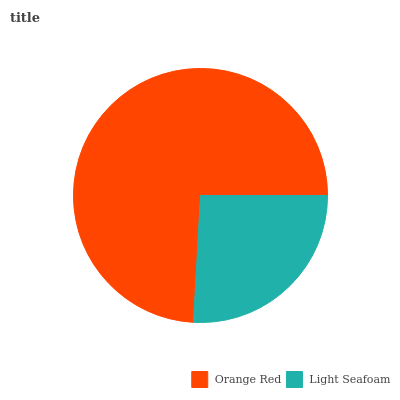Is Light Seafoam the minimum?
Answer yes or no. Yes. Is Orange Red the maximum?
Answer yes or no. Yes. Is Light Seafoam the maximum?
Answer yes or no. No. Is Orange Red greater than Light Seafoam?
Answer yes or no. Yes. Is Light Seafoam less than Orange Red?
Answer yes or no. Yes. Is Light Seafoam greater than Orange Red?
Answer yes or no. No. Is Orange Red less than Light Seafoam?
Answer yes or no. No. Is Orange Red the high median?
Answer yes or no. Yes. Is Light Seafoam the low median?
Answer yes or no. Yes. Is Light Seafoam the high median?
Answer yes or no. No. Is Orange Red the low median?
Answer yes or no. No. 